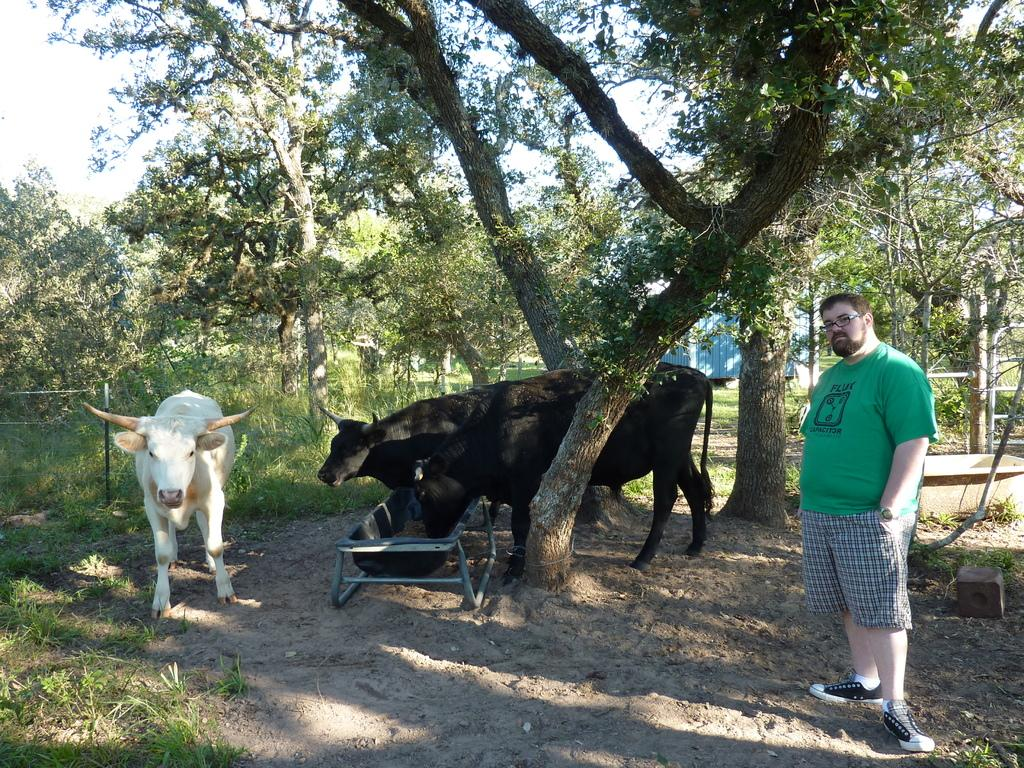How many animals are present in the image? There are three animals in the image. What are the animals doing in the image? One of the animals is eating food. Can you describe the person's position in the image? There is a person standing on the right side of the image. What can be seen in the background of the image? There are trees and grass in the background of the image. What type of industry can be seen in the background of the image? There is no industry present in the image; it features trees and grass in the background. What color is the mitten that the cow is wearing in the image? There is no cow or mitten present in the image. 